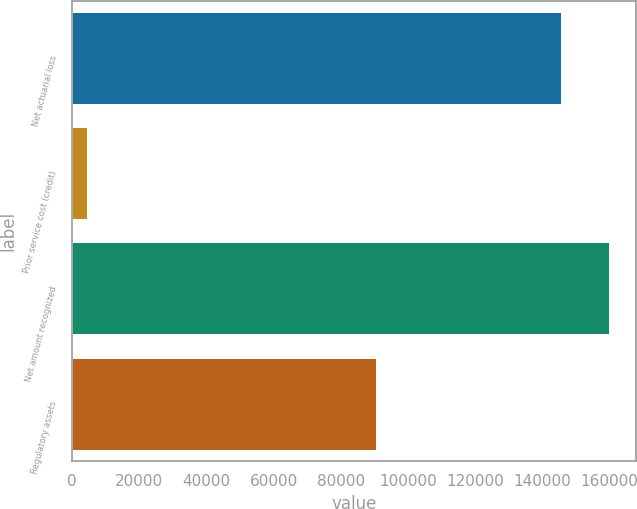Convert chart to OTSL. <chart><loc_0><loc_0><loc_500><loc_500><bar_chart><fcel>Net actuarial loss<fcel>Prior service cost (credit)<fcel>Net amount recognized<fcel>Regulatory assets<nl><fcel>145376<fcel>4418<fcel>159914<fcel>90380<nl></chart> 